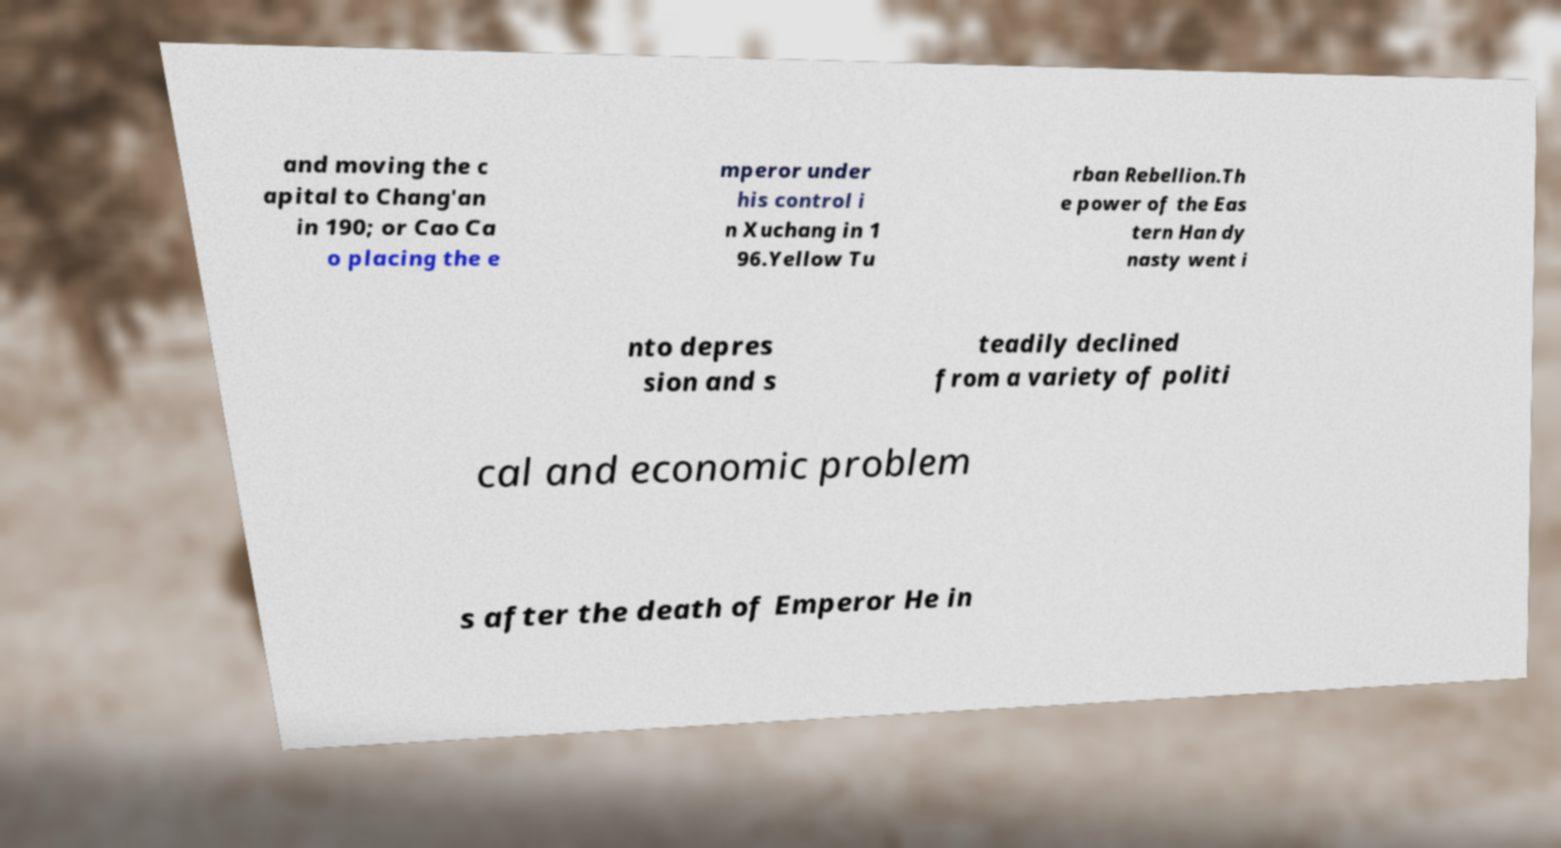Please identify and transcribe the text found in this image. and moving the c apital to Chang'an in 190; or Cao Ca o placing the e mperor under his control i n Xuchang in 1 96.Yellow Tu rban Rebellion.Th e power of the Eas tern Han dy nasty went i nto depres sion and s teadily declined from a variety of politi cal and economic problem s after the death of Emperor He in 